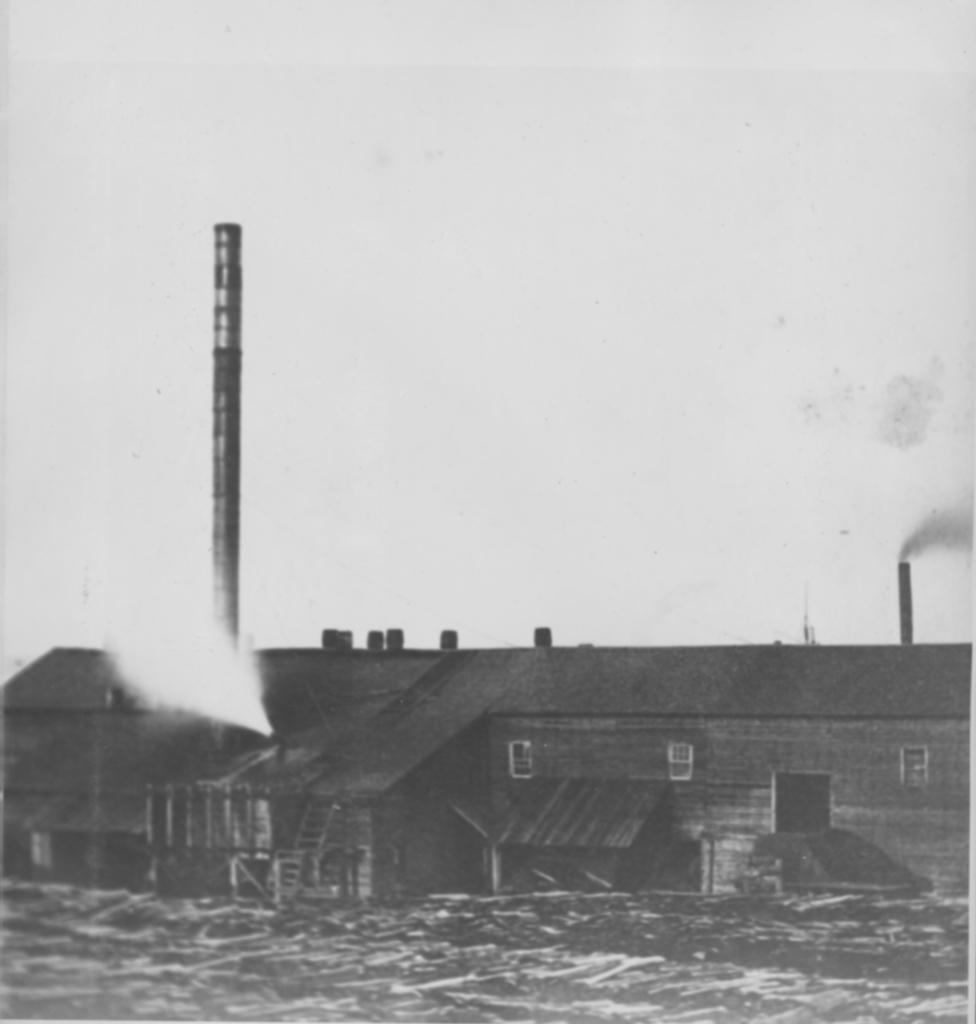Please provide a concise description of this image. In this image I can see a building. Both side of this image I can see smoke and I can also see this image is black and white in colour. 